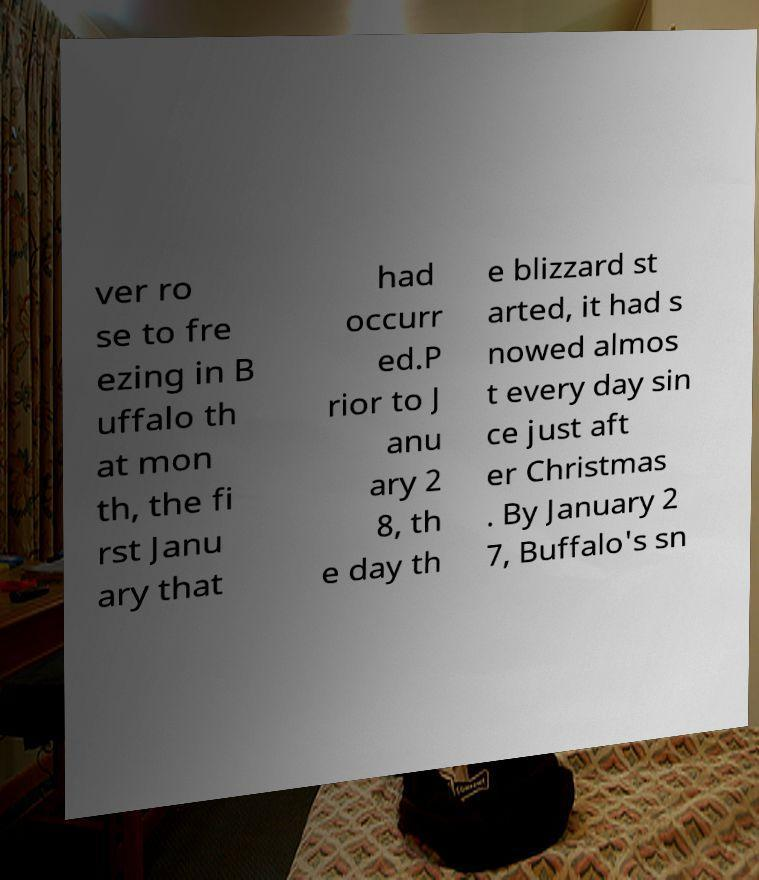What messages or text are displayed in this image? I need them in a readable, typed format. ver ro se to fre ezing in B uffalo th at mon th, the fi rst Janu ary that had occurr ed.P rior to J anu ary 2 8, th e day th e blizzard st arted, it had s nowed almos t every day sin ce just aft er Christmas . By January 2 7, Buffalo's sn 